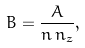Convert formula to latex. <formula><loc_0><loc_0><loc_500><loc_500>B = \frac { A } { n \, n _ { z } } ,</formula> 